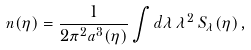Convert formula to latex. <formula><loc_0><loc_0><loc_500><loc_500>n ( \eta ) = \frac { 1 } { 2 \pi ^ { 2 } a ^ { 3 } ( \eta ) } \int d \lambda \, \lambda ^ { 2 } \, S _ { \lambda } ( \eta ) \, ,</formula> 